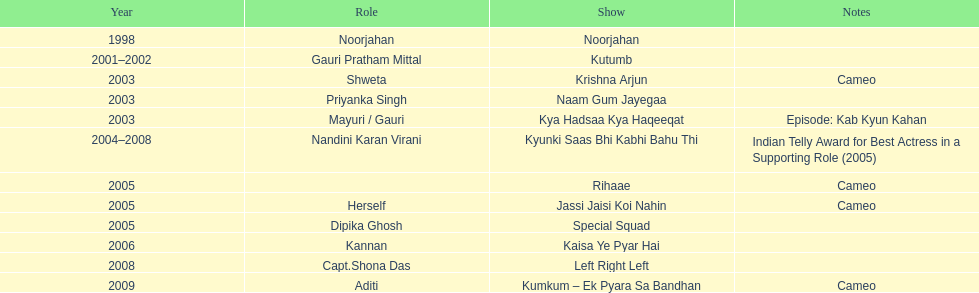What was the most years a show lasted? 4. 